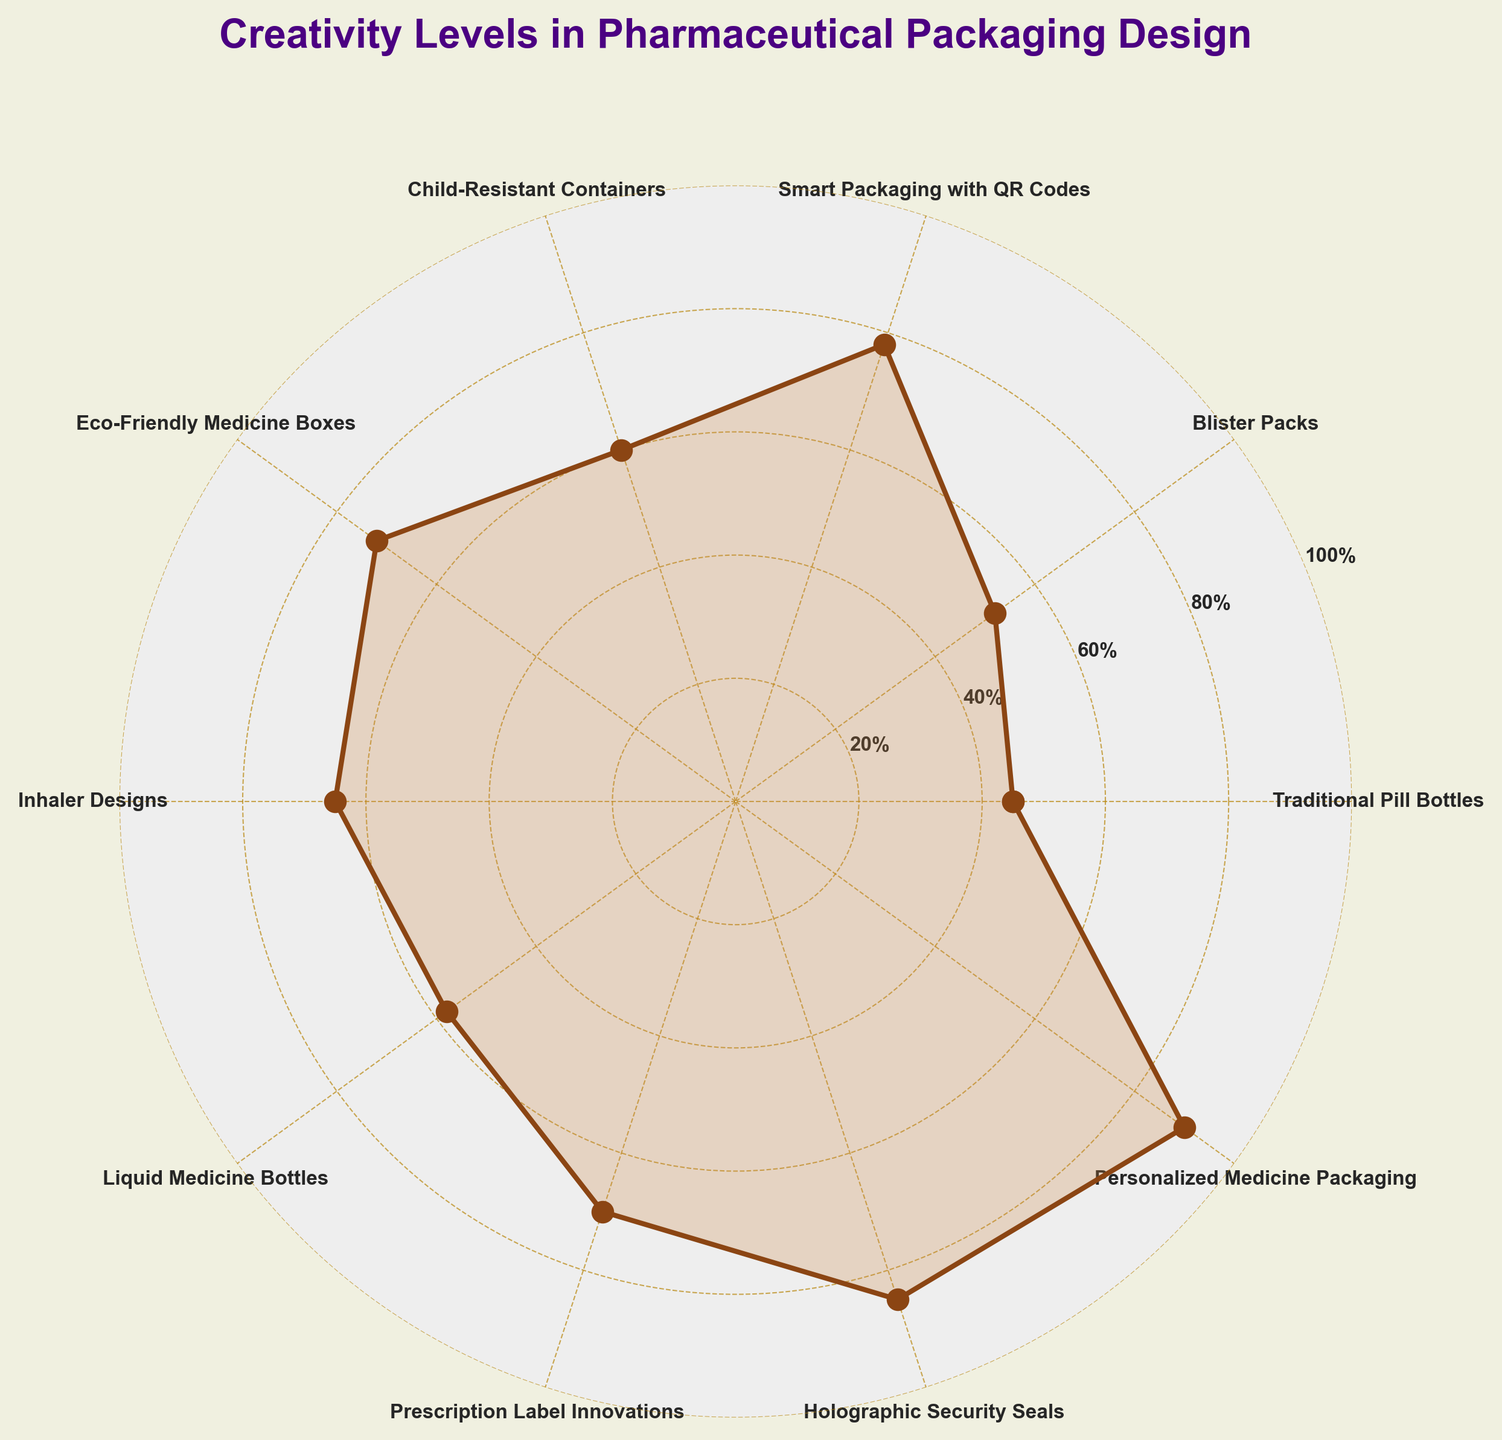What's the title of the figure? The title is found at the top of the figure. It is written in bold, in a bigger font size compared to the other text elements.
Answer: Creativity Levels in Pharmaceutical Packaging Design What is the value associated with 'Blister Packs'? To find the value, look for the segment labeled 'Blister Packs' and read the associated value from the plot or its data point.
Answer: 52 Which category has the highest creativity level? Identify the segment with the highest data point value on the gauge chart.
Answer: Personalized Medicine Packaging How many categories have a creativity level higher than 60? Count the segments that have values above 60 in the plot.
Answer: 6 What is the average creativity level of the categories 'Traditional Pill Bottles', 'Blister Packs', and 'Holographic Security Seals'? Add the values of these categories (45, 52, 85) and divide by the number of categories, which is 3. Calculation: (45 + 52 + 85) / 3 = 60.67
Answer: 60.67 Which category has the lowest creativity level and what is that level? Find the category with the lowest data point value on the plot.
Answer: Traditional Pill Bottles (45) What's the difference in creativity level between 'Eco-Friendly Medicine Boxes' and 'Inhaler Designs'? Subtract the creativity level of 'Inhaler Designs' from that of 'Eco-Friendly Medicine Boxes'. Calculation: 72 - 65 = 7
Answer: 7 What is the most common range for the creativity levels in the figure? Examine the distribution of values and identify the most frequent range. Most values range between 60-80.
Answer: 60-80 If you were to find the median creativity level, what would it be? Arrange the values in ascending order and find the middle value. Sorted values: [45, 52, 58, 60, 65, 70, 72, 78, 85, 90]. The median is the average of the 5th and 6th values: (65+70)/2 = 67.5
Answer: 67.5 